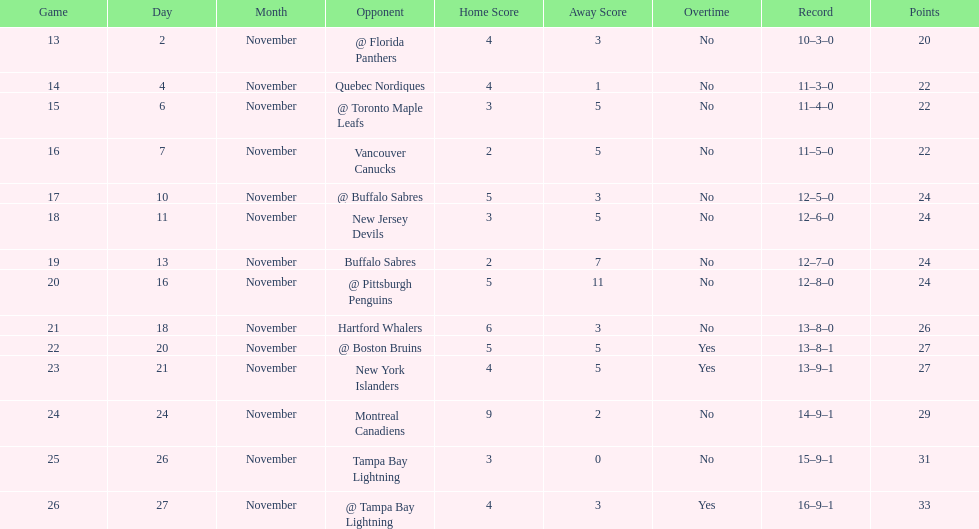What was the number of wins the philadelphia flyers had? 35. 